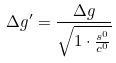Convert formula to latex. <formula><loc_0><loc_0><loc_500><loc_500>\Delta g ^ { \prime } = \frac { \Delta g } { \sqrt { 1 \cdot \frac { s ^ { 0 } } { c ^ { 0 } } } }</formula> 